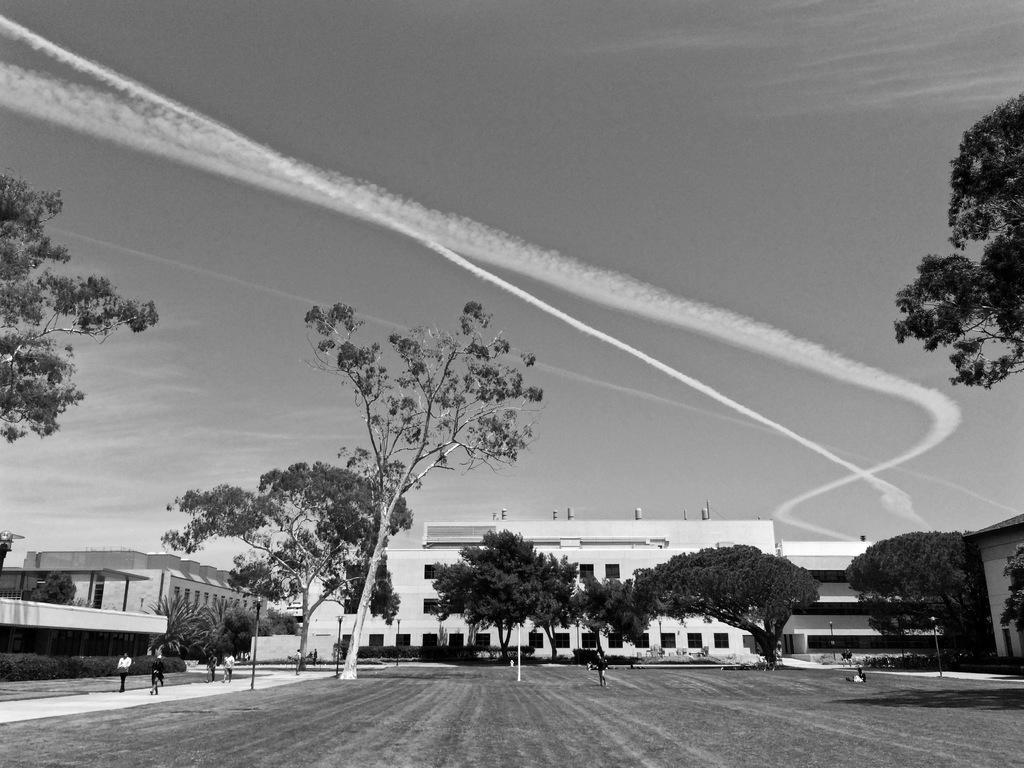What type of vegetation can be seen in the image? There are trees in the image. What type of structures are present in the image? There are white buildings in the image. What is the ground covered with in the image? The ground is covered with grass in the image. What can be seen in the sky in the image? The sky is visible in the image. What might indicate recent activity in the image? There is rocket smoke in the image, which suggests a recent rocket launch. Can you see anyone playing a musical note on a swing in the image? There is no musical note or swing present in the image. How does the rocket pull itself up into the sky in the image? The image does not show the rocket pulling itself up; it only shows the rocket smoke after the launch. 